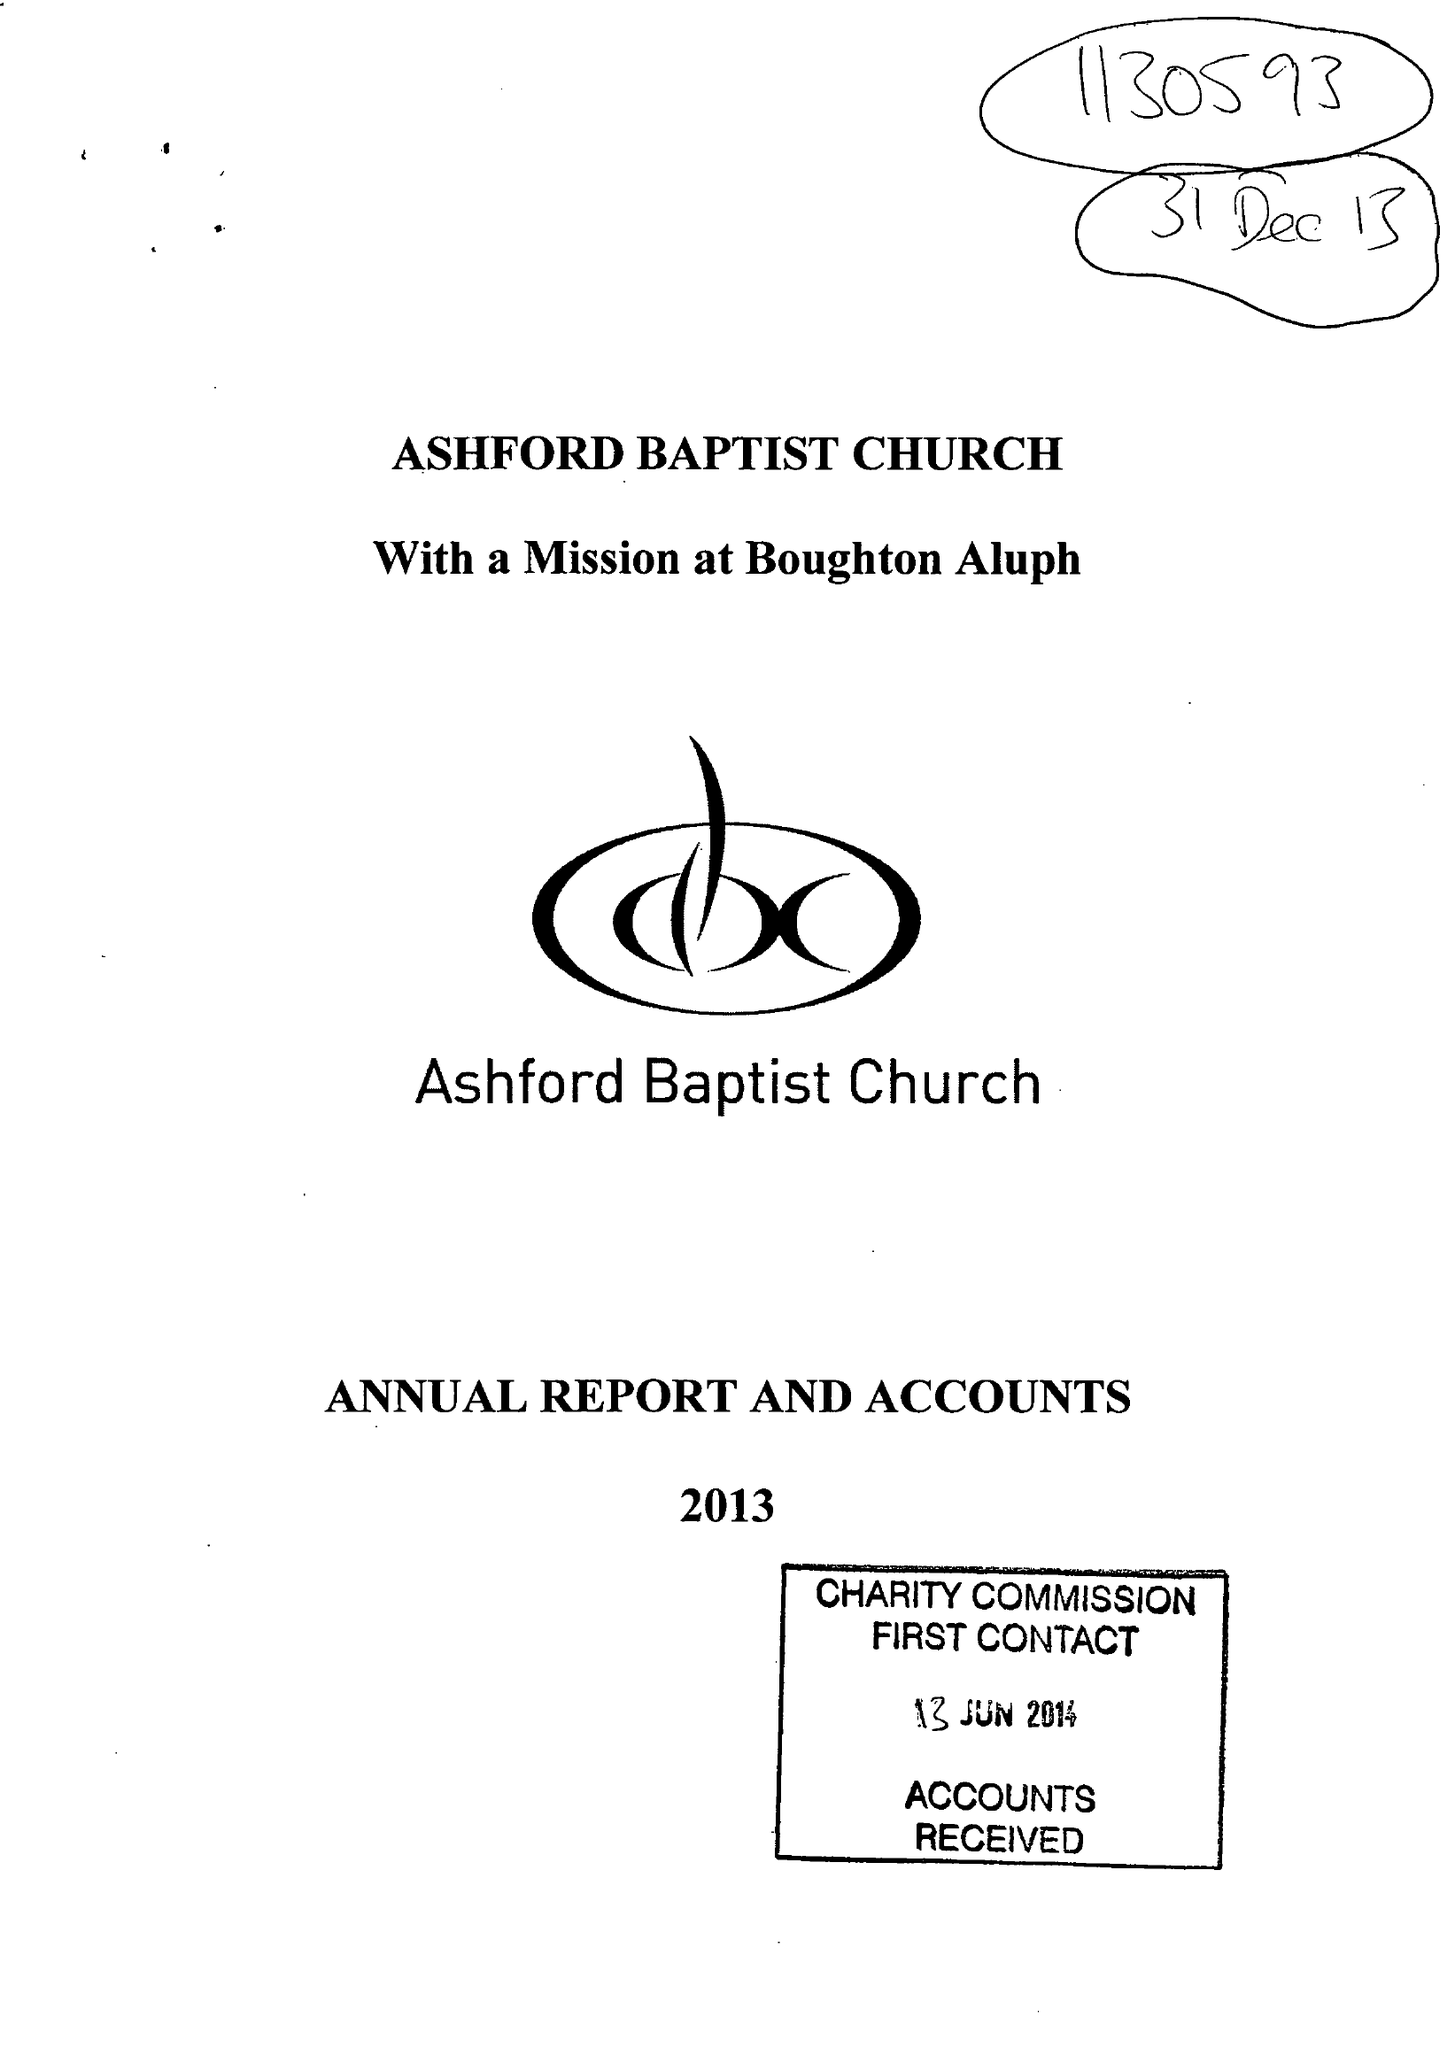What is the value for the address__postcode?
Answer the question using a single word or phrase. TN23 1PS 